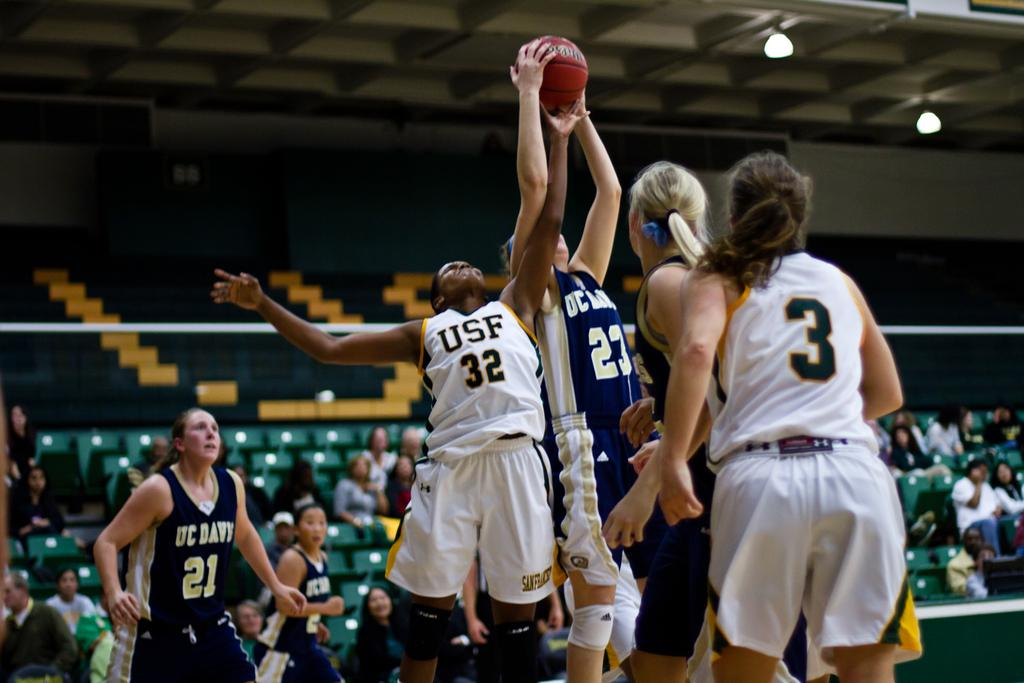Provide a one-sentence caption for the provided image. The player from USF goes up for the jumpball at the basketball game. 